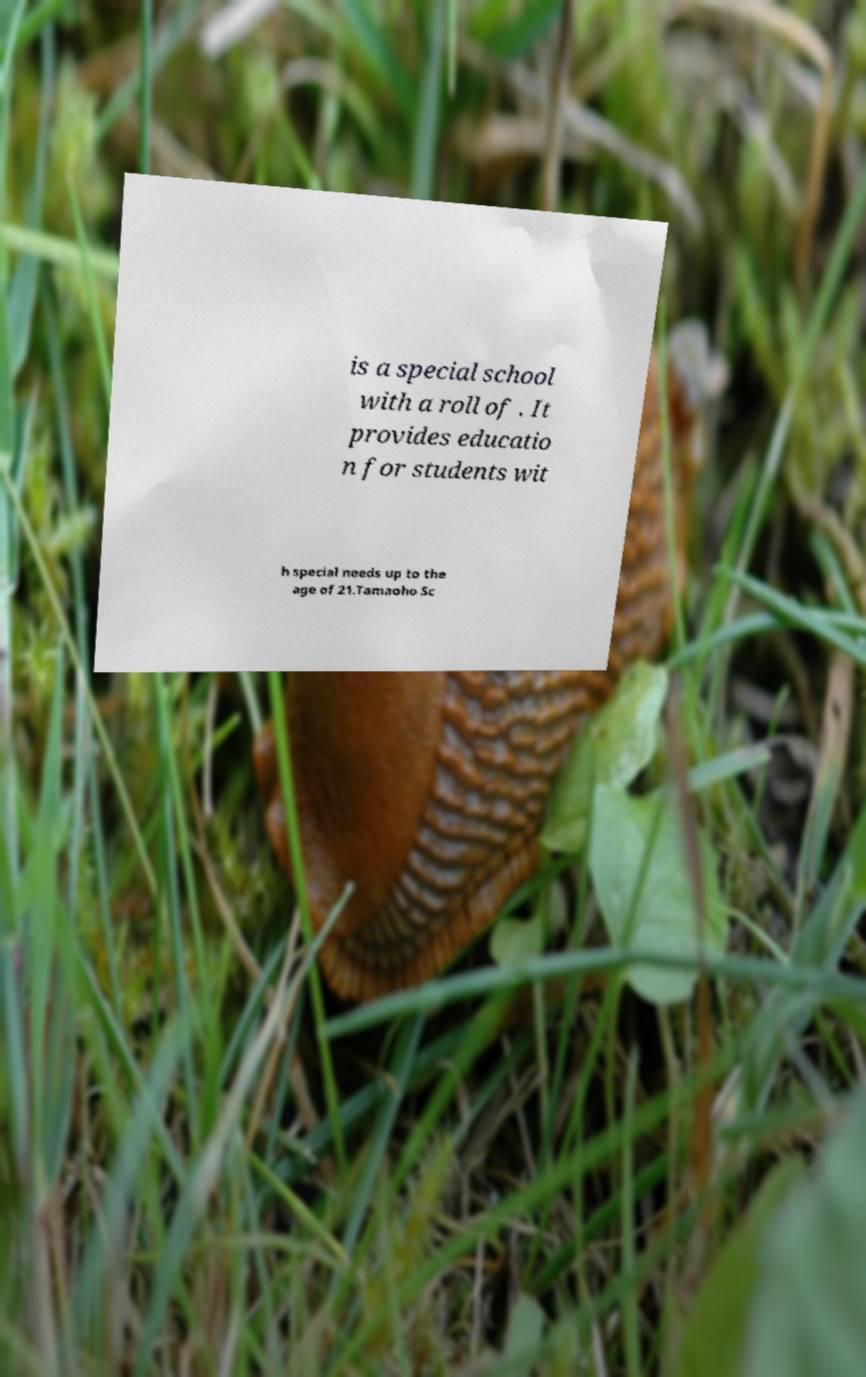There's text embedded in this image that I need extracted. Can you transcribe it verbatim? is a special school with a roll of . It provides educatio n for students wit h special needs up to the age of 21.Tamaoho Sc 